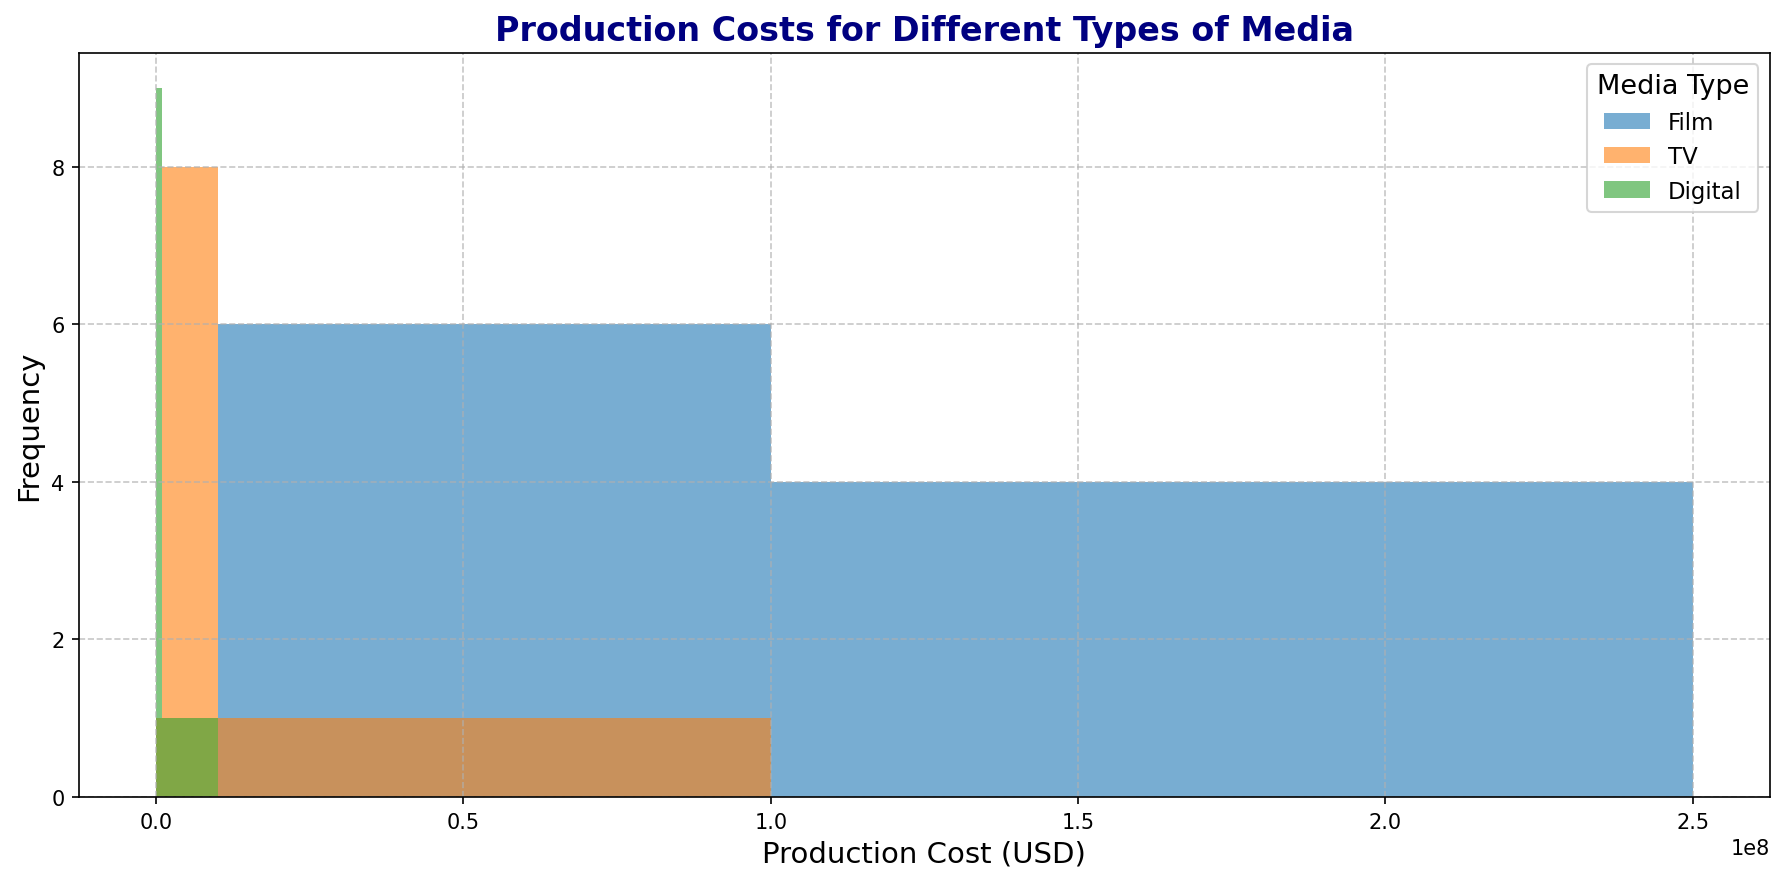What is the range of production costs for TV shows? The range of production costs is obtained by subtracting the minimum production cost from the maximum production cost for TV shows. From the histogram, these values are $500,000 and $10,000,000 respectively. Thus, the range is $10,000,000 - $500,000.
Answer: $9,500,000 Which media type has the highest maximum production cost? Identify the maximum production cost for each media type from the histogram. For films, it is $250,000,000; for TV, it is $10,000,000; and for digital media, it is $1,000,000. Therefore, films have the highest production cost.
Answer: Film How many bins show TV production costs? Count the bins on the histogram where the TV production costs fall into. The bins that show TV costs are between $0 and $10,000,000.
Answer: 4 Which media type has the most even distribution of production costs across the bins? From the histogram, observe the distribution of costs across the bins for each media type. Digital media shows evenly distributed production costs across the bins compared to films and TV.
Answer: Digital What is the most common range of production costs for films? From the histogram, identify the range with the highest bar for films. The concentration is highest in the $100,000,000 - $250,000,000 range.
Answer: $100,000,000 - $250,000,000 Compare the frequency of production costs in the $1,000,000 - $10,000,000 range for TV and Digital media. Look at the heights of the bars in the $1,000,000 - $10,000,000 range. TV has higher frequency bars in this range compared to Digital media.
Answer: TV What percentage of the bins show film production costs higher than $100,000,000? Count the number of bins where film production costs exceed $100,000,000 (from $100,000,000 to $250,000,000). There are 2 such bins out of a total of 4 bins. Thus, the percentage is (2/4)*100%.
Answer: 50% Which media type has its production costs entirely within the first two bins? Check the histogram to determine which media type has all costs only in the first two bins ($0 to $1,000,000). Digital media fits this criterion.
Answer: Digital What is the total frequency for TV production costs across all bins? Sum the frequencies (heights of the bars) in each bin for TV production costs. The total is the sum of counts in all bins.
Answer: 10 In which cost range is there no production cost for digital media? Identify any bin where the bar height for digital media is zero. From the histogram, there are no production costs for digital media beyond $1,000,000.
Answer: More than $1,000,000 